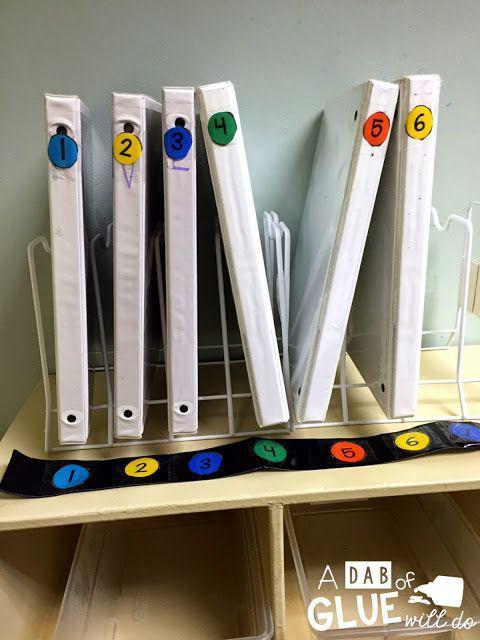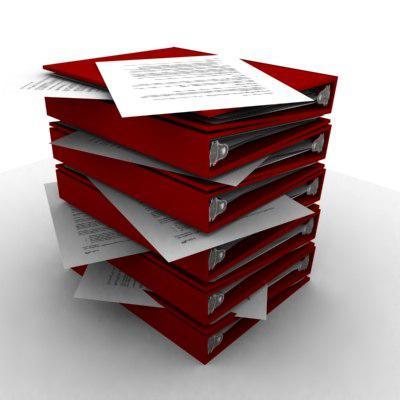The first image is the image on the left, the second image is the image on the right. For the images shown, is this caption "One image shows overlapping binders of different solid colors arranged in a single curved, arching line." true? Answer yes or no. No. 